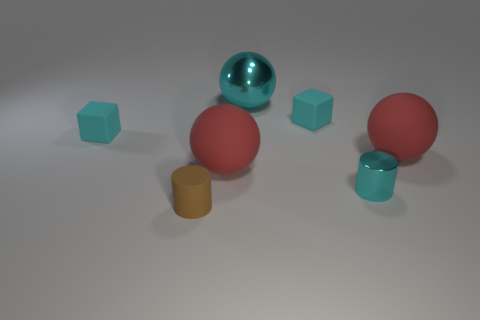What is the material of the cube that is to the left of the big ball that is left of the big metallic thing?
Offer a very short reply. Rubber. The metal thing that is the same size as the brown rubber cylinder is what color?
Ensure brevity in your answer.  Cyan. There is a brown thing; does it have the same shape as the cyan rubber object that is to the left of the matte cylinder?
Your answer should be very brief. No. What is the shape of the metallic object that is the same color as the small metallic cylinder?
Your answer should be compact. Sphere. How many big red objects are behind the small cyan rubber cube left of the brown matte thing in front of the large shiny sphere?
Give a very brief answer. 0. What size is the cyan rubber object that is to the right of the tiny object in front of the small metal object?
Provide a succinct answer. Small. The cyan cylinder that is the same material as the big cyan thing is what size?
Your response must be concise. Small. There is a big thing that is in front of the cyan sphere and to the left of the tiny cyan metal cylinder; what is its shape?
Provide a short and direct response. Sphere. Is the number of matte cylinders that are behind the small cyan cylinder the same as the number of tiny gray metallic balls?
Provide a short and direct response. Yes. What number of objects are either large purple cylinders or red rubber objects to the right of the cyan ball?
Keep it short and to the point. 1. 